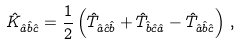Convert formula to latex. <formula><loc_0><loc_0><loc_500><loc_500>\hat { K } _ { \hat { a } \hat { b } \hat { c } } = { \frac { 1 } { 2 } } \left ( \hat { T } _ { \hat { a } \hat { c } \hat { b } } + \hat { T } _ { \hat { b } \hat { c } \hat { a } } - \hat { T } _ { \hat { a } \hat { b } \hat { c } } \right ) \, ,</formula> 